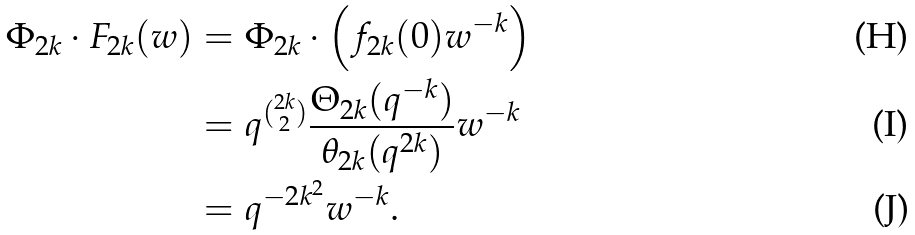Convert formula to latex. <formula><loc_0><loc_0><loc_500><loc_500>\Phi _ { 2 k } \cdot F _ { 2 k } ( w ) & = \Phi _ { 2 k } \cdot \left ( f _ { 2 k } ( 0 ) w ^ { - k } \right ) \\ & = q ^ { \binom { 2 k } { 2 } } \frac { \Theta _ { 2 k } ( q ^ { - k } ) } { \theta _ { 2 k } ( q ^ { 2 k } ) } w ^ { - k } \\ & = q ^ { - 2 k ^ { 2 } } w ^ { - k } .</formula> 